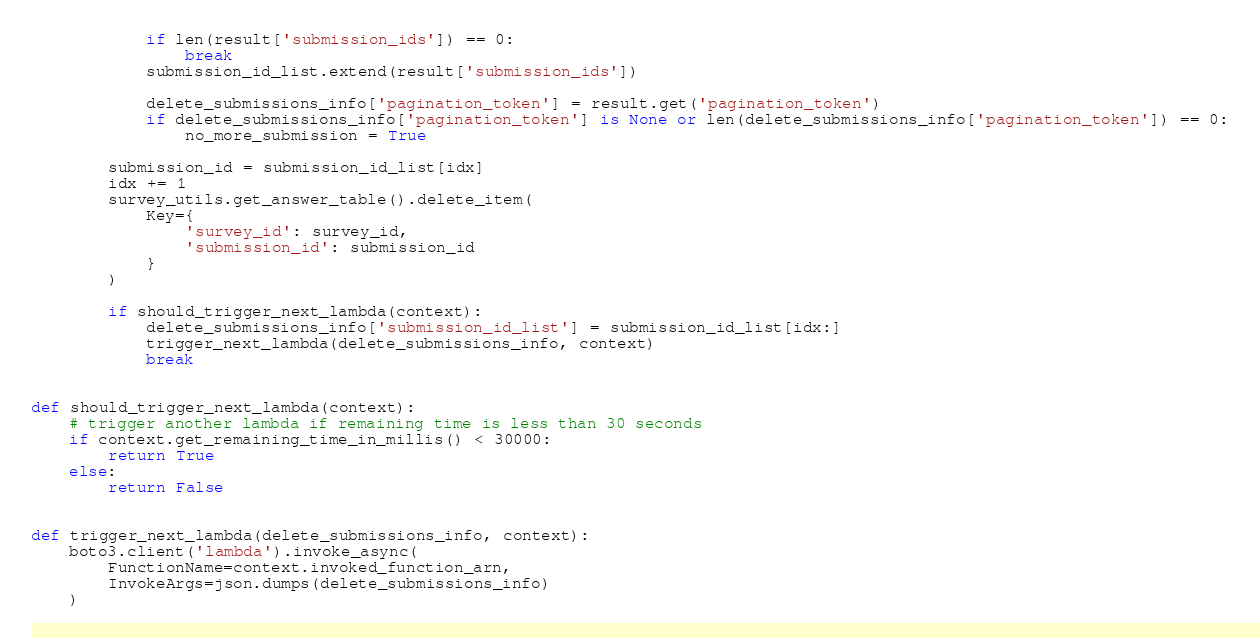Convert code to text. <code><loc_0><loc_0><loc_500><loc_500><_Python_>            if len(result['submission_ids']) == 0:
                break
            submission_id_list.extend(result['submission_ids'])

            delete_submissions_info['pagination_token'] = result.get('pagination_token')
            if delete_submissions_info['pagination_token'] is None or len(delete_submissions_info['pagination_token']) == 0:
                no_more_submission = True

        submission_id = submission_id_list[idx]
        idx += 1
        survey_utils.get_answer_table().delete_item(
            Key={
                'survey_id': survey_id,
                'submission_id': submission_id
            }
        )

        if should_trigger_next_lambda(context):
            delete_submissions_info['submission_id_list'] = submission_id_list[idx:]
            trigger_next_lambda(delete_submissions_info, context)
            break


def should_trigger_next_lambda(context):
    # trigger another lambda if remaining time is less than 30 seconds
    if context.get_remaining_time_in_millis() < 30000:
        return True
    else:
        return False


def trigger_next_lambda(delete_submissions_info, context):
    boto3.client('lambda').invoke_async(
        FunctionName=context.invoked_function_arn,
        InvokeArgs=json.dumps(delete_submissions_info)
    )
</code> 